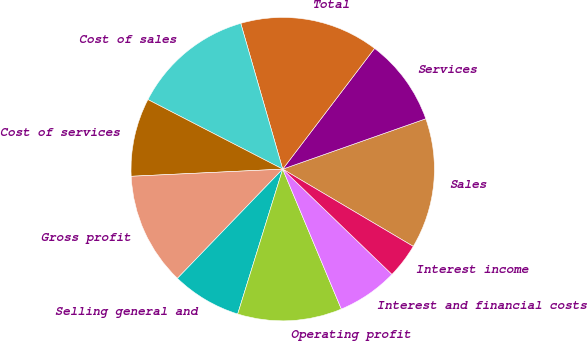<chart> <loc_0><loc_0><loc_500><loc_500><pie_chart><fcel>Sales<fcel>Services<fcel>Total<fcel>Cost of sales<fcel>Cost of services<fcel>Gross profit<fcel>Selling general and<fcel>Operating profit<fcel>Interest and financial costs<fcel>Interest income<nl><fcel>13.89%<fcel>9.26%<fcel>14.81%<fcel>12.96%<fcel>8.33%<fcel>12.04%<fcel>7.41%<fcel>11.11%<fcel>6.48%<fcel>3.7%<nl></chart> 